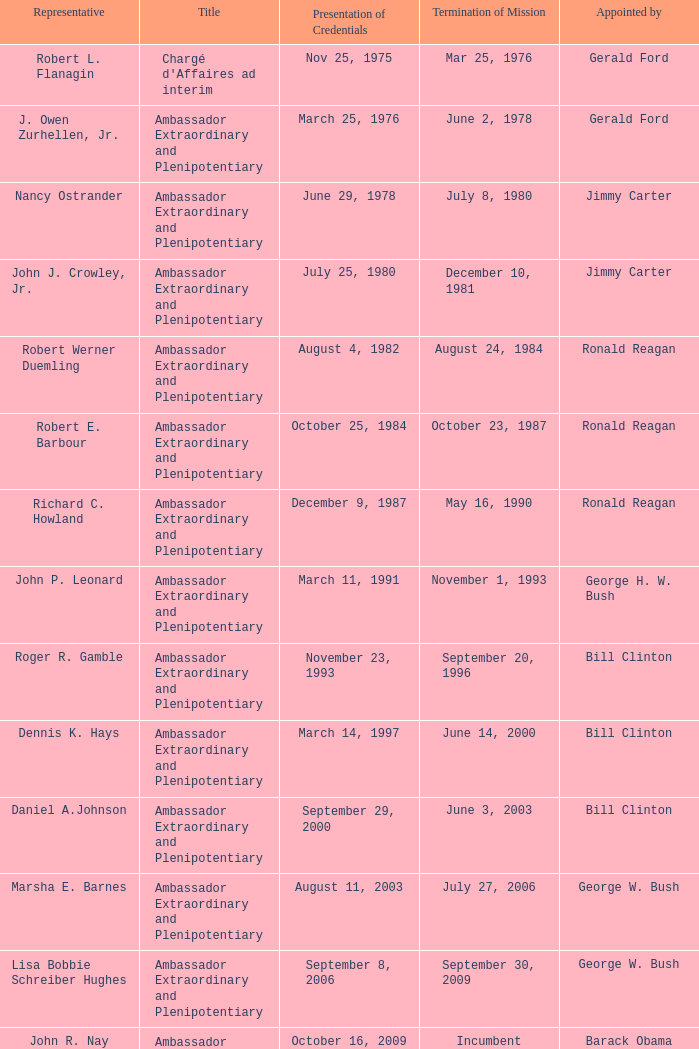What was the Termination of Mission date for the ambassador who was appointed by Barack Obama? Incumbent. 